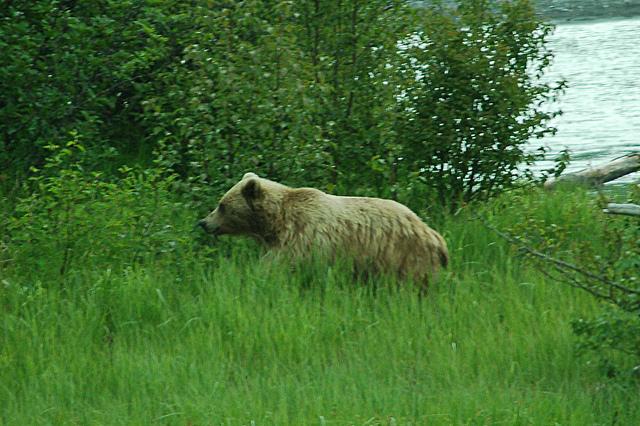What is the bear doing?
Be succinct. Walking. What kind of animal is this?
Keep it brief. Bear. Is this in the wild?
Quick response, please. Yes. Are there trees behind the bear?
Quick response, please. Yes. Is the bear wet?
Short answer required. No. What is the bear standing in?
Give a very brief answer. Grass. Can you see teeth?
Write a very short answer. No. Is the bear in a zoo?
Quick response, please. No. Could this bear be contained?
Quick response, please. No. 